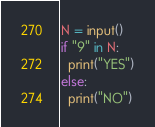<code> <loc_0><loc_0><loc_500><loc_500><_Python_>N = input()
if "9" in N:
  print("YES")
else:
  print("NO")</code> 